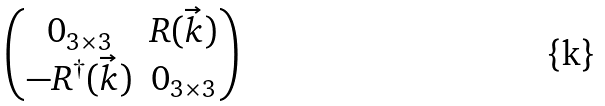<formula> <loc_0><loc_0><loc_500><loc_500>\begin{pmatrix} 0 _ { 3 \times 3 } & R ( \vec { k } ) \\ - R ^ { \dagger } ( \vec { k } ) & 0 _ { 3 \times 3 } \end{pmatrix}</formula> 